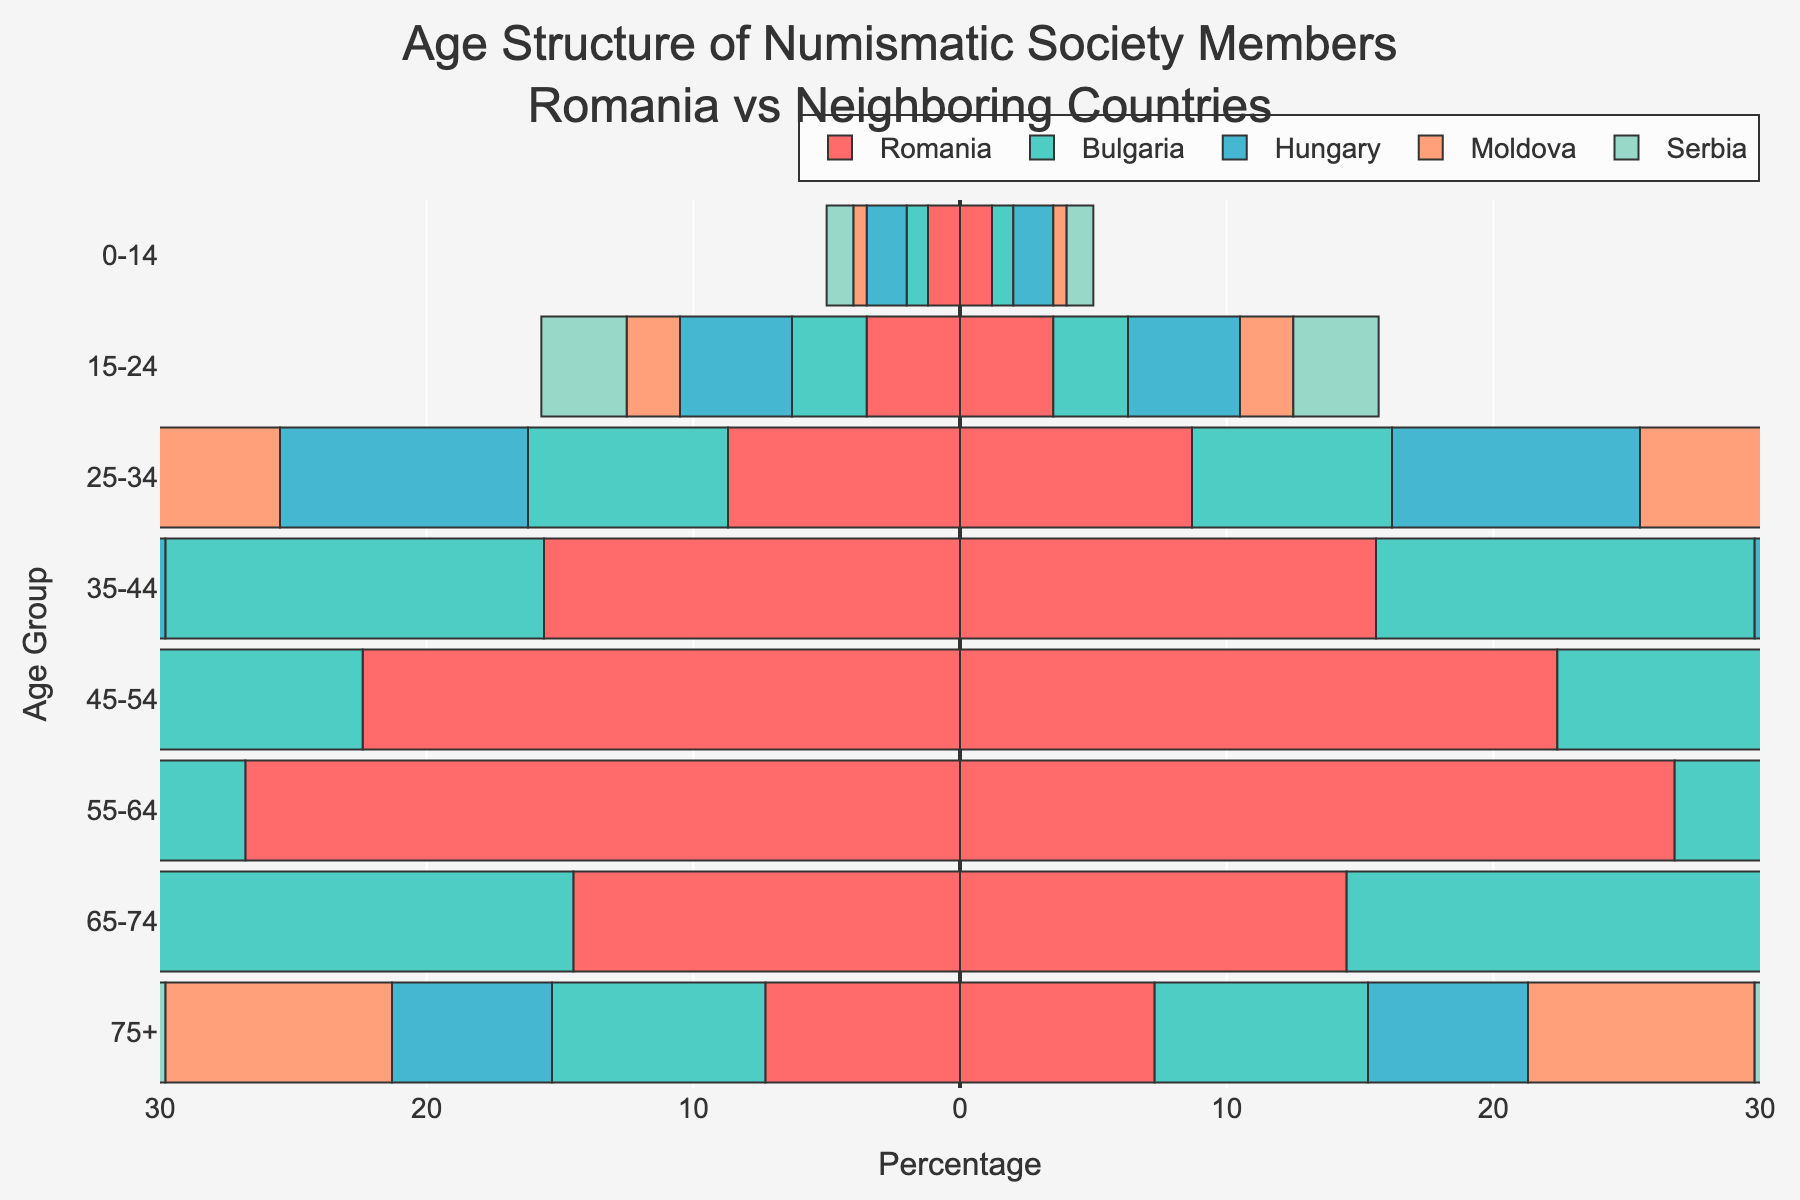Which age group has the highest percentage of numismatic society members in Romania? The highest percentage bar in Romania's data is 26.8% for the age group 55-64.
Answer: 55-64 How does the percentage of members aged 0-14 in Romania compare to Hungary? Romania has a lower percentage of members aged 0-14 at 1.2%, compared to Hungary's 1.5%.
Answer: Lower What is the average percentage of the 35-44 age group across all five countries? Adding the percentages for Romania, Bulgaria, Hungary, Moldova, and Serbia (15.6 + 14.2 + 16.8 + 13.5 + 15.0) and dividing by 5 gives (75.1 / 5).
Answer: 15.02 In which country is the 55-64 age group the most represented? The highest percentage in the 55-64 age group is in Moldova at 29.2%.
Answer: Moldova Which age group has the smallest differences in percentage among all countries? The 0-14 age group has the smallest range of differences, from 0.5% to 1.5%, which is a spread of 1.0%.
Answer: 0-14 Is the percentage of members aged 65-74 higher in Bulgaria or Romania? Bulgaria has a higher percentage of members aged 65-74 at 17.2%, compared to Romania's 14.5%.
Answer: Bulgaria What age group in Serbia has the closest percentage to Romania's members aged 75+? Serbia's percentage of members aged 75+ is equal to Romania's at 8.0%.
Answer: 75+ Compare the percentages of the 25-34 age group in Romania and Moldova. Which is higher? Romania has a higher percentage at 8.7% compared to Moldova's 6.8%.
Answer: Romania What is the combined percentage of members aged 45-54 and 55-64 in Bulgaria? Adding the percentages for Bulgaria in these groups (21.0 + 28.5) gives 49.5%.
Answer: 49.5 Across which countries is the age group 35-44 most consistently represented? Looking at the data, the age group 35-44 shows relatively consistent percentages around 15%, with minimal deviation (14.2-16.8).
Answer: 35-44 